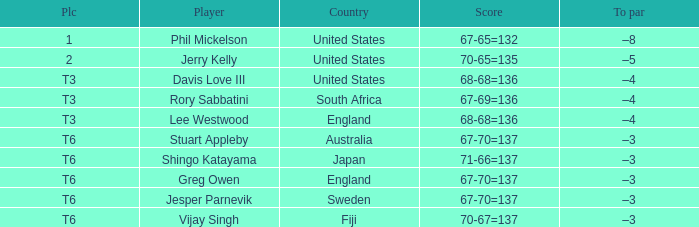Identify the fijian player. Vijay Singh. Could you help me parse every detail presented in this table? {'header': ['Plc', 'Player', 'Country', 'Score', 'To par'], 'rows': [['1', 'Phil Mickelson', 'United States', '67-65=132', '–8'], ['2', 'Jerry Kelly', 'United States', '70-65=135', '–5'], ['T3', 'Davis Love III', 'United States', '68-68=136', '–4'], ['T3', 'Rory Sabbatini', 'South Africa', '67-69=136', '–4'], ['T3', 'Lee Westwood', 'England', '68-68=136', '–4'], ['T6', 'Stuart Appleby', 'Australia', '67-70=137', '–3'], ['T6', 'Shingo Katayama', 'Japan', '71-66=137', '–3'], ['T6', 'Greg Owen', 'England', '67-70=137', '–3'], ['T6', 'Jesper Parnevik', 'Sweden', '67-70=137', '–3'], ['T6', 'Vijay Singh', 'Fiji', '70-67=137', '–3']]} 